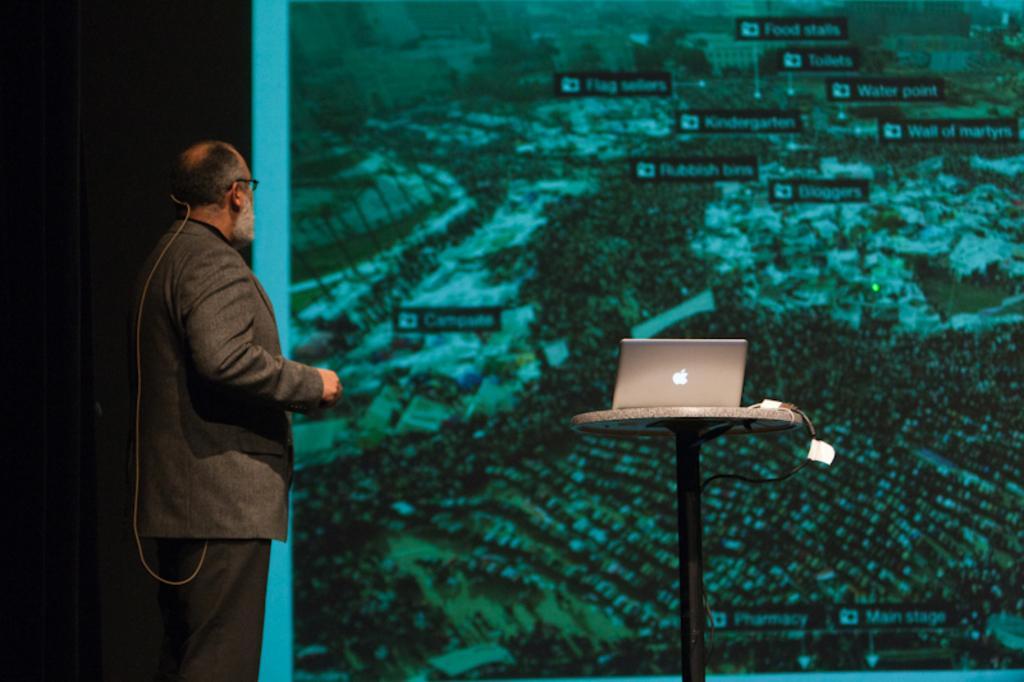In one or two sentences, can you explain what this image depicts? Here we can see a man and he is in a suit. There is a laptop on the table. In the background there is a screen. 